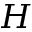<formula> <loc_0><loc_0><loc_500><loc_500>H</formula> 